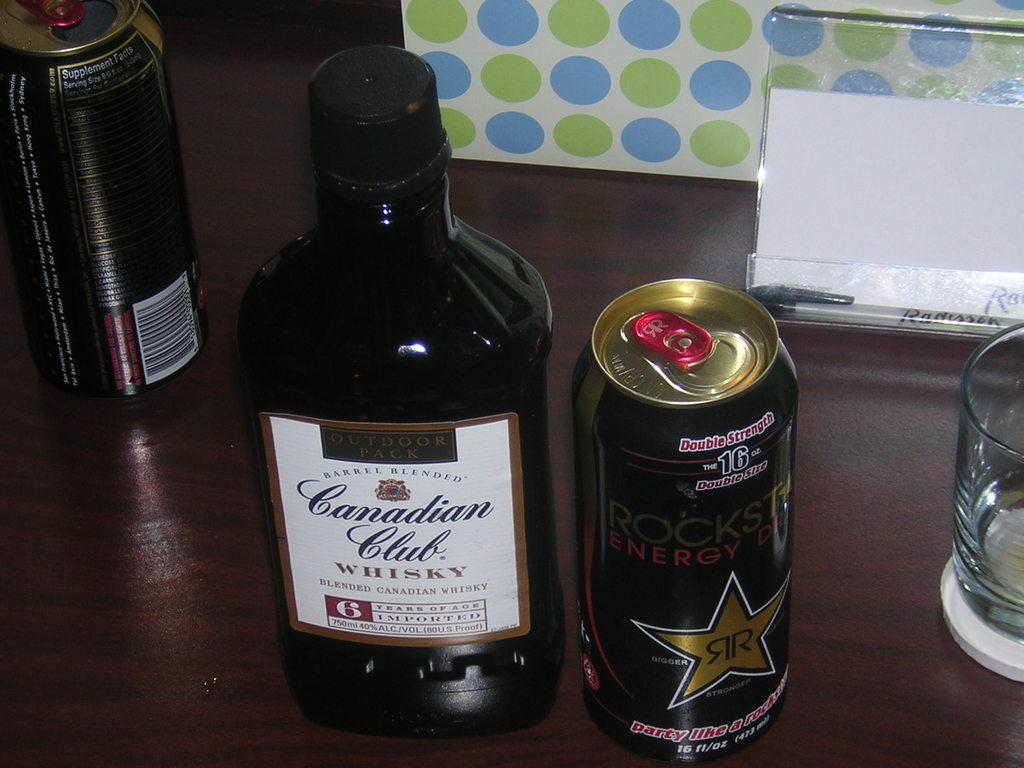<image>
Relay a brief, clear account of the picture shown. A bottle of Canadian Club and an energy drink side by side on a table. 